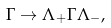<formula> <loc_0><loc_0><loc_500><loc_500>\Gamma \to \Lambda _ { + } \Gamma \Lambda _ { - } ,</formula> 